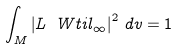<formula> <loc_0><loc_0><loc_500><loc_500>\int _ { M } \left | L \ W t i l _ { \infty } \right | ^ { 2 } \, d v = 1</formula> 